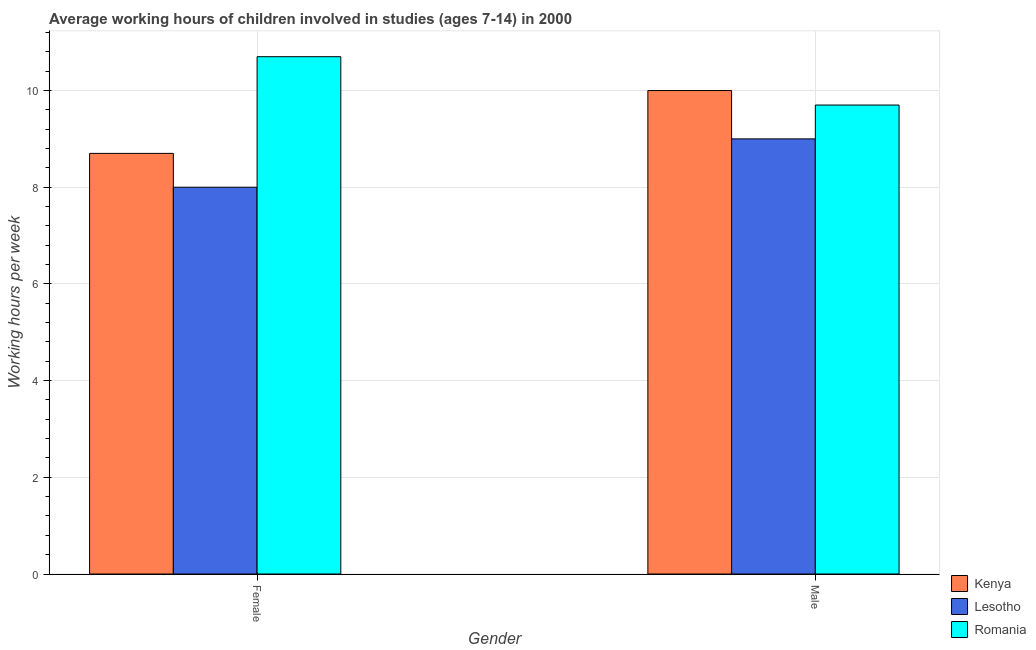Are the number of bars per tick equal to the number of legend labels?
Make the answer very short. Yes. Are the number of bars on each tick of the X-axis equal?
Your answer should be very brief. Yes. How many bars are there on the 2nd tick from the right?
Make the answer very short. 3. What is the label of the 2nd group of bars from the left?
Offer a very short reply. Male. What is the average working hour of female children in Romania?
Your answer should be compact. 10.7. Across all countries, what is the maximum average working hour of male children?
Your answer should be compact. 10. Across all countries, what is the minimum average working hour of male children?
Offer a terse response. 9. In which country was the average working hour of female children maximum?
Make the answer very short. Romania. In which country was the average working hour of male children minimum?
Your response must be concise. Lesotho. What is the total average working hour of female children in the graph?
Keep it short and to the point. 27.4. What is the difference between the average working hour of male children in Kenya and the average working hour of female children in Lesotho?
Provide a short and direct response. 2. What is the average average working hour of female children per country?
Your answer should be compact. 9.13. What is the difference between the average working hour of male children and average working hour of female children in Lesotho?
Keep it short and to the point. 1. What is the ratio of the average working hour of female children in Lesotho to that in Romania?
Make the answer very short. 0.75. What does the 3rd bar from the left in Female represents?
Ensure brevity in your answer.  Romania. What does the 3rd bar from the right in Female represents?
Provide a short and direct response. Kenya. How many bars are there?
Your answer should be very brief. 6. Are all the bars in the graph horizontal?
Provide a short and direct response. No. What is the difference between two consecutive major ticks on the Y-axis?
Your answer should be very brief. 2. Does the graph contain any zero values?
Make the answer very short. No. Does the graph contain grids?
Your answer should be compact. Yes. How are the legend labels stacked?
Offer a very short reply. Vertical. What is the title of the graph?
Provide a succinct answer. Average working hours of children involved in studies (ages 7-14) in 2000. What is the label or title of the X-axis?
Provide a succinct answer. Gender. What is the label or title of the Y-axis?
Your response must be concise. Working hours per week. What is the Working hours per week of Kenya in Female?
Offer a terse response. 8.7. What is the Working hours per week of Romania in Female?
Your answer should be very brief. 10.7. What is the Working hours per week in Kenya in Male?
Give a very brief answer. 10. What is the Working hours per week of Lesotho in Male?
Offer a very short reply. 9. Across all Gender, what is the maximum Working hours per week of Kenya?
Make the answer very short. 10. Across all Gender, what is the maximum Working hours per week of Romania?
Keep it short and to the point. 10.7. Across all Gender, what is the minimum Working hours per week of Kenya?
Your answer should be very brief. 8.7. Across all Gender, what is the minimum Working hours per week of Lesotho?
Provide a succinct answer. 8. What is the total Working hours per week in Kenya in the graph?
Your answer should be compact. 18.7. What is the total Working hours per week in Lesotho in the graph?
Provide a short and direct response. 17. What is the total Working hours per week of Romania in the graph?
Keep it short and to the point. 20.4. What is the difference between the Working hours per week of Romania in Female and that in Male?
Make the answer very short. 1. What is the difference between the Working hours per week in Kenya in Female and the Working hours per week in Romania in Male?
Keep it short and to the point. -1. What is the average Working hours per week in Kenya per Gender?
Provide a succinct answer. 9.35. What is the average Working hours per week of Lesotho per Gender?
Keep it short and to the point. 8.5. What is the difference between the Working hours per week in Lesotho and Working hours per week in Romania in Female?
Ensure brevity in your answer.  -2.7. What is the difference between the Working hours per week in Kenya and Working hours per week in Lesotho in Male?
Provide a short and direct response. 1. What is the difference between the Working hours per week of Kenya and Working hours per week of Romania in Male?
Give a very brief answer. 0.3. What is the ratio of the Working hours per week of Kenya in Female to that in Male?
Make the answer very short. 0.87. What is the ratio of the Working hours per week in Lesotho in Female to that in Male?
Offer a terse response. 0.89. What is the ratio of the Working hours per week of Romania in Female to that in Male?
Offer a terse response. 1.1. What is the difference between the highest and the lowest Working hours per week of Lesotho?
Provide a short and direct response. 1. What is the difference between the highest and the lowest Working hours per week in Romania?
Your answer should be compact. 1. 